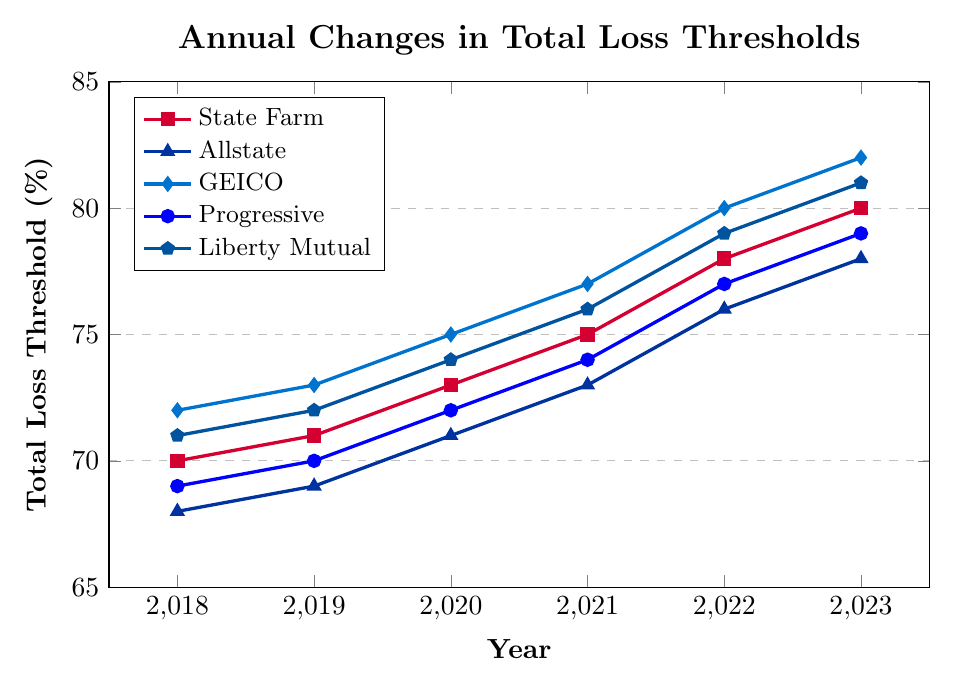What is the total loss threshold percentage for GEICO in 2021? Locate the 2021 data point for GEICO, which is marked with a diamond shape. The value at this point is 77%.
Answer: 77% Which year did Progressive's total loss threshold exceed 75% for the first time? Follow the line representing Progressive, marked with circles, and check the threshold values year by year. Progressive exceeded 75% for the first time in 2022 with a value of 77%.
Answer: 2022 In which year did Allstate and Liberty Mutual have the same total loss threshold percentage? Find the points where Allstate (triangles) and Liberty Mutual (pentagons) are at the same value. In 2019, both had a total loss threshold of 69% and 72%.
Answer: Never Compare the total loss threshold percentages of State Farm and GEICO in 2023. Which one is higher and by how much? Find the 2023 values for State Farm (squares) and GEICO (diamonds). State Farm is at 80%, and GEICO is at 82%. GEICO's threshold is higher by 2%.
Answer: GEICO by 2% What is the overall trend in total loss thresholds for all the insurance companies from 2018 to 2023? Observe each line representing the insurance companies over the years. All lines show an upward trend, indicating that total loss thresholds have increased for all companies from 2018 to 2023.
Answer: Upward trend Which insurance company had the highest total loss threshold in 2020 and what was the value? In 2020, check the highest points for each insurance company. GEICO (diamond) had the highest threshold at 75%.
Answer: GEICO at 75% By what percentage did Liberty Mutual's total loss threshold change from 2018 to 2023? Find the values for Liberty Mutual (pentagons) in 2018 and 2023. The values are 71% and 81%, respectively. The percentage change is calculated as (81 - 71)/71 * 100% ≈ 14%.
Answer: 14% How many years did State Farm have a higher total loss threshold than Progressive? Compare the annual data points for State Farm (squares) and Progressive (circles). State Farm had higher values in 2020, 2021, 2022, and 2023.
Answer: 4 years Which company shows the steepest increase in total loss thresholds between any two consecutive years? Assess the slopes of the lines for all companies between each consecutive year. GEICO, from 2021 to 2022, increased by 3 percentage points (from 77% to 80%).
Answer: GEICO (2021-2022) Between which years did Allstate see the largest increase in its total loss threshold? Examine the yearly increments for Allstate (triangles). The largest increase is 3 percentage points from 2021 to 2022, as it went from 73% to 76%.
Answer: 2021-2022 